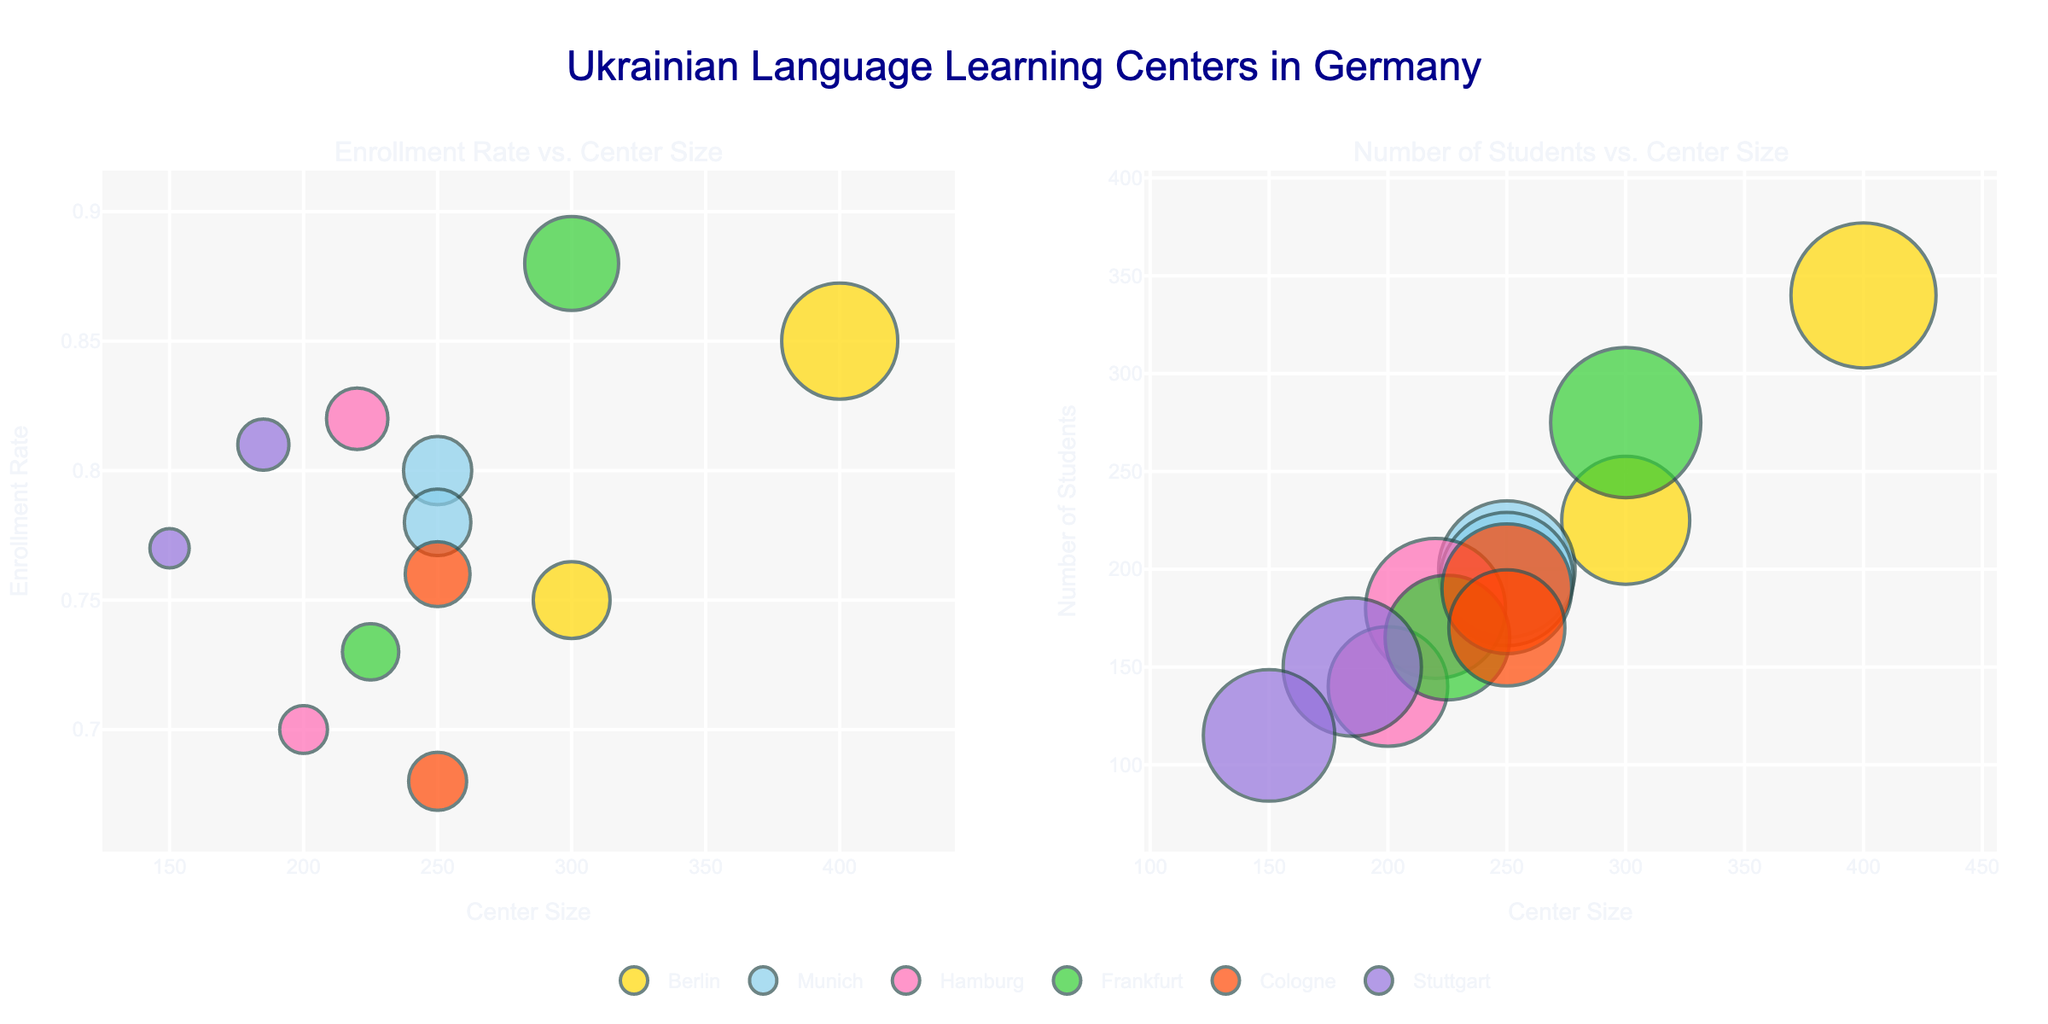How many language learning centers are represented in Berlin? Looking at the bubble chart, we can see each bubble represents a language learning center; counting the bubbles for Berlin, we see there are 2 learning centers.
Answer: 2 Which city has the learning center with the highest enrollment rate? Checking the "Enrollment Rate vs. Center Size" subplot, we see that the highest enrollment rate is about 0.88, which belongs to Frankfurt.
Answer: Frankfurt How does the number of students at Cologne Ukrainian Institute compare to Eurasia Language School? In the "Number of Students vs. Center Size" subplot, Cologne Ukrainian Institute has 190 students, while Eurasia Language School has 170 students. Thus, Cologne Ukrainian Institute has more students.
Answer: Cologne Ukrainian Institute has more students Which city has the smallest learning center in terms of size? On both subplots, looking at the x-axis labeled 'Center Size,' we identify Stuttgart Ukrainian Language School Stuttgart with a size of 150, the smallest among all centers.
Answer: Stuttgart What is the enrollment rate for the Kyiv Learning Hub in Munich? Referring to the "Enrollment Rate vs. Center Size" subplot, the bubble labeled "Kyiv Learning Hub" shows an enrollment rate of 0.78.
Answer: 0.78 Which learning center has the largest number of students in Berlin? From the "Number of Students vs. Center Size" subplot, the largest bubble for Berlin represents the Language Academy Berlin with 340 students.
Answer: Language Academy Berlin How many students are served by learning centers in Hamburg overall? Summing up the number of students from both Hamburg centers: Ukraine Language Center Hamburg has 180 students, and Slavic Language Institute has 140. 180 + 140 = 320.
Answer: 320 Between the two learning centers in Frankfurt, which one has a higher enrollment rate and by how much? In the "Enrollment Rate vs. Center Size" subplot, Frankfurt Ukrainian Cultural Center has an enrollment rate of 0.88 and Vista Language School has 0.73. The difference is 0.88 - 0.73 = 0.15.
Answer: Frankfurt Ukrainian Cultural Center by 0.15 Are there any cities where all learning centers have an enrollment rate above 0.80? Observing "Enrollment Rate vs. Center Size" subplot, Frankfurt and Berlin each have one center below 0.80. Stuttgart, Munich, and Cologne also have centers below 0.80. Hamburg's Ukraine Language Center Hamburg has an enrollment rate of 0.82, but Slavic Language Institute has 0.70. So, no city has all centers above 0.80.
Answer: No Compare the center sizes of Ukrainian Heritage School and Kyiv Learning Hub in Munich. Which one is larger and by how much? By looking at the x-axis in "Enrollment Rate vs. Center Size" subplot: Ukrainian Heritage School has a center size of 250, Kyiv Learning Hub also has a center size of 250. So, they are the same size.
Answer: They are the same size 